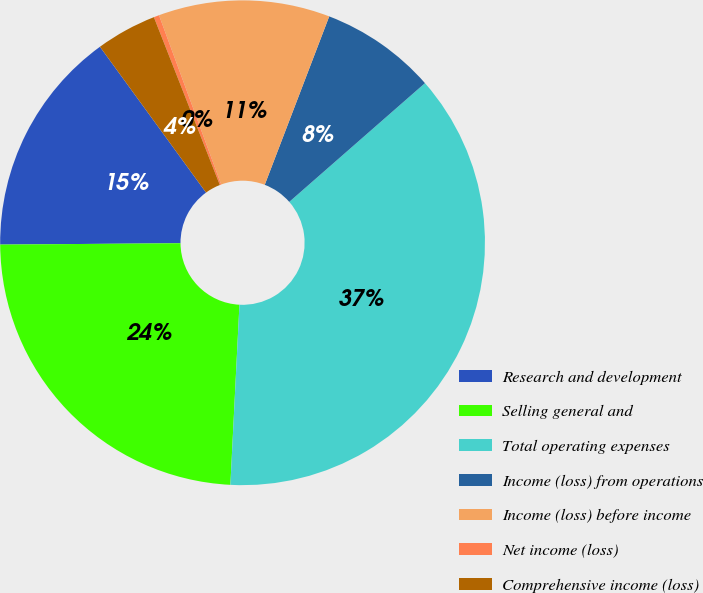<chart> <loc_0><loc_0><loc_500><loc_500><pie_chart><fcel>Research and development<fcel>Selling general and<fcel>Total operating expenses<fcel>Income (loss) from operations<fcel>Income (loss) before income<fcel>Net income (loss)<fcel>Comprehensive income (loss)<nl><fcel>15.11%<fcel>24.08%<fcel>37.24%<fcel>7.74%<fcel>11.42%<fcel>0.36%<fcel>4.05%<nl></chart> 